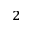Convert formula to latex. <formula><loc_0><loc_0><loc_500><loc_500>^ { 2 }</formula> 